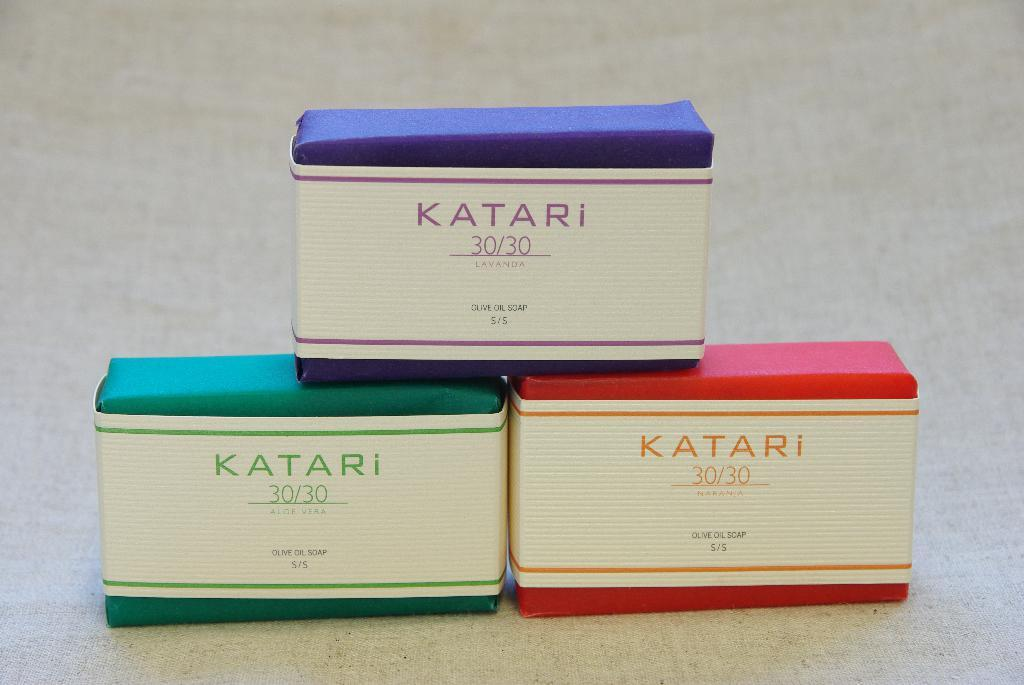How many soap boxes are visible in the image? There are three soap boxes in the image. What distinguishes the soap boxes from one another? The soap boxes are of different colors. Where are the soap boxes located in the image? Two soap boxes are on the floor, and another soap box is on top of the two on the floor. What information is provided on the soap boxes? There is text on the soap boxes. What year is depicted on the soap boxes in the image? There is no year depicted on the soap boxes in the image. How many family members are shown interacting with the soap boxes in the image? There are no family members present in the image; it only features soap boxes. 